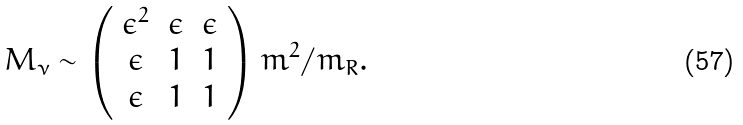<formula> <loc_0><loc_0><loc_500><loc_500>M _ { \nu } \sim \left ( \begin{array} { c c c } \epsilon ^ { 2 } & \epsilon & \epsilon \\ \epsilon & 1 & 1 \\ \epsilon & 1 & 1 \end{array} \right ) m ^ { 2 } / m _ { R } .</formula> 